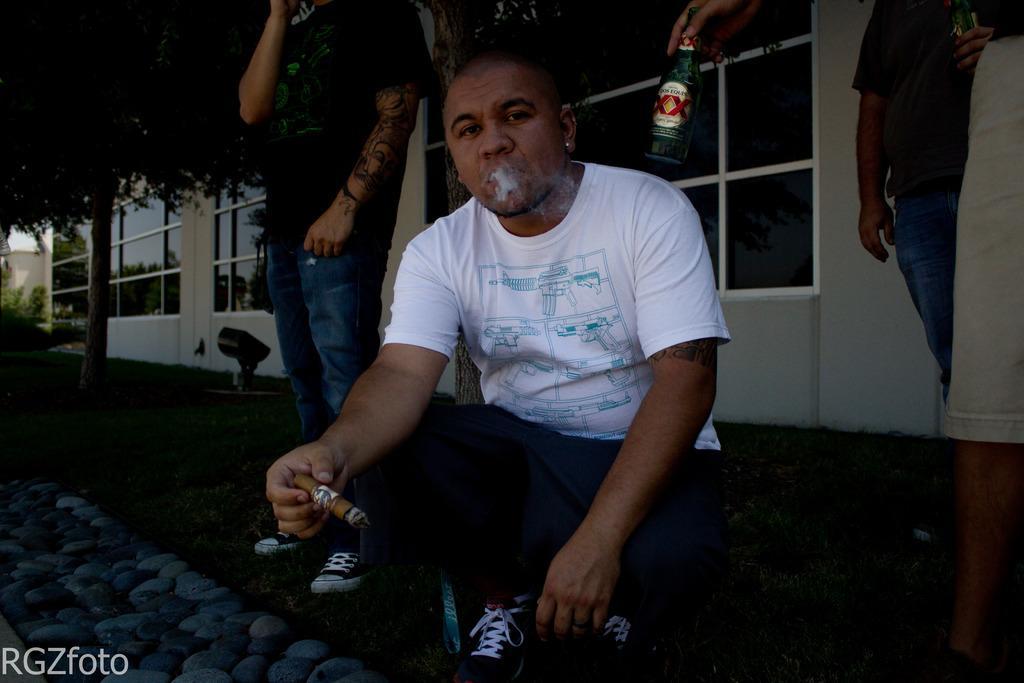Describe this image in one or two sentences. In this image a person is sitting on the grassland. He is holding a cigarette in his hand. Beside him there is a person standing on the grass land having a tree and few plants. Right side a person is standing. Top of the image where I can see a person's hand holding a bottle. Background there is a building. Left bottom there is a cobblestone path. 